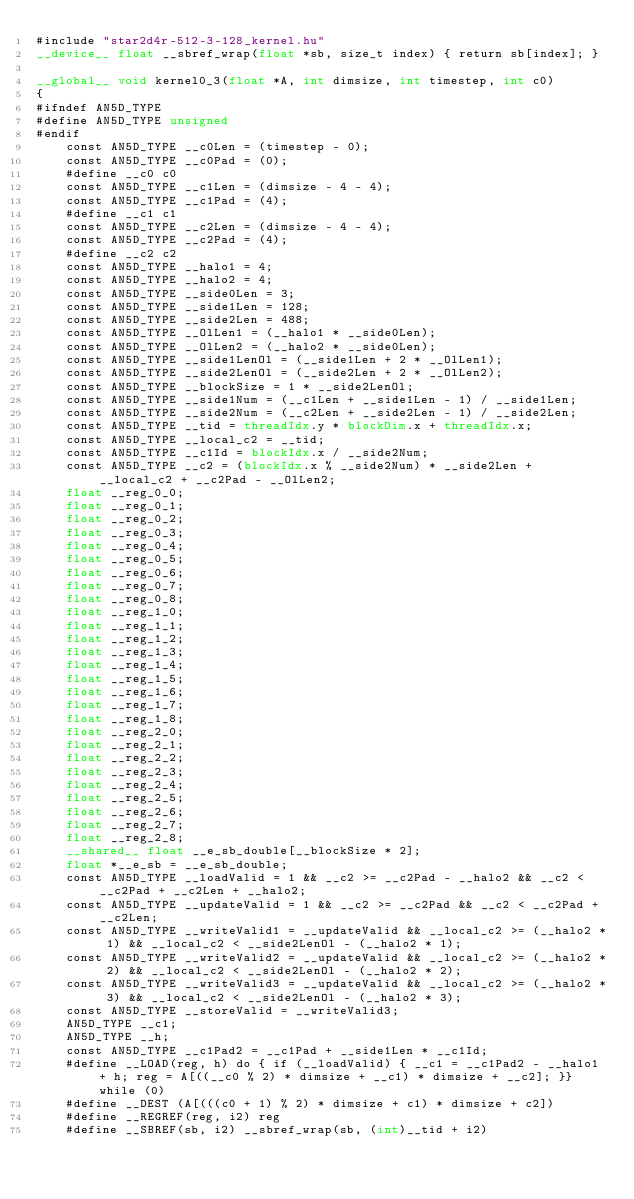<code> <loc_0><loc_0><loc_500><loc_500><_Cuda_>#include "star2d4r-512-3-128_kernel.hu"
__device__ float __sbref_wrap(float *sb, size_t index) { return sb[index]; }

__global__ void kernel0_3(float *A, int dimsize, int timestep, int c0)
{
#ifndef AN5D_TYPE
#define AN5D_TYPE unsigned
#endif
    const AN5D_TYPE __c0Len = (timestep - 0);
    const AN5D_TYPE __c0Pad = (0);
    #define __c0 c0
    const AN5D_TYPE __c1Len = (dimsize - 4 - 4);
    const AN5D_TYPE __c1Pad = (4);
    #define __c1 c1
    const AN5D_TYPE __c2Len = (dimsize - 4 - 4);
    const AN5D_TYPE __c2Pad = (4);
    #define __c2 c2
    const AN5D_TYPE __halo1 = 4;
    const AN5D_TYPE __halo2 = 4;
    const AN5D_TYPE __side0Len = 3;
    const AN5D_TYPE __side1Len = 128;
    const AN5D_TYPE __side2Len = 488;
    const AN5D_TYPE __OlLen1 = (__halo1 * __side0Len);
    const AN5D_TYPE __OlLen2 = (__halo2 * __side0Len);
    const AN5D_TYPE __side1LenOl = (__side1Len + 2 * __OlLen1);
    const AN5D_TYPE __side2LenOl = (__side2Len + 2 * __OlLen2);
    const AN5D_TYPE __blockSize = 1 * __side2LenOl;
    const AN5D_TYPE __side1Num = (__c1Len + __side1Len - 1) / __side1Len;
    const AN5D_TYPE __side2Num = (__c2Len + __side2Len - 1) / __side2Len;
    const AN5D_TYPE __tid = threadIdx.y * blockDim.x + threadIdx.x;
    const AN5D_TYPE __local_c2 = __tid;
    const AN5D_TYPE __c1Id = blockIdx.x / __side2Num;
    const AN5D_TYPE __c2 = (blockIdx.x % __side2Num) * __side2Len + __local_c2 + __c2Pad - __OlLen2;
    float __reg_0_0;
    float __reg_0_1;
    float __reg_0_2;
    float __reg_0_3;
    float __reg_0_4;
    float __reg_0_5;
    float __reg_0_6;
    float __reg_0_7;
    float __reg_0_8;
    float __reg_1_0;
    float __reg_1_1;
    float __reg_1_2;
    float __reg_1_3;
    float __reg_1_4;
    float __reg_1_5;
    float __reg_1_6;
    float __reg_1_7;
    float __reg_1_8;
    float __reg_2_0;
    float __reg_2_1;
    float __reg_2_2;
    float __reg_2_3;
    float __reg_2_4;
    float __reg_2_5;
    float __reg_2_6;
    float __reg_2_7;
    float __reg_2_8;
    __shared__ float __e_sb_double[__blockSize * 2];
    float *__e_sb = __e_sb_double;
    const AN5D_TYPE __loadValid = 1 && __c2 >= __c2Pad - __halo2 && __c2 < __c2Pad + __c2Len + __halo2;
    const AN5D_TYPE __updateValid = 1 && __c2 >= __c2Pad && __c2 < __c2Pad + __c2Len;
    const AN5D_TYPE __writeValid1 = __updateValid && __local_c2 >= (__halo2 * 1) && __local_c2 < __side2LenOl - (__halo2 * 1);
    const AN5D_TYPE __writeValid2 = __updateValid && __local_c2 >= (__halo2 * 2) && __local_c2 < __side2LenOl - (__halo2 * 2);
    const AN5D_TYPE __writeValid3 = __updateValid && __local_c2 >= (__halo2 * 3) && __local_c2 < __side2LenOl - (__halo2 * 3);
    const AN5D_TYPE __storeValid = __writeValid3;
    AN5D_TYPE __c1;
    AN5D_TYPE __h;
    const AN5D_TYPE __c1Pad2 = __c1Pad + __side1Len * __c1Id;
    #define __LOAD(reg, h) do { if (__loadValid) { __c1 = __c1Pad2 - __halo1 + h; reg = A[((__c0 % 2) * dimsize + __c1) * dimsize + __c2]; }} while (0)
    #define __DEST (A[(((c0 + 1) % 2) * dimsize + c1) * dimsize + c2])
    #define __REGREF(reg, i2) reg
    #define __SBREF(sb, i2) __sbref_wrap(sb, (int)__tid + i2)</code> 